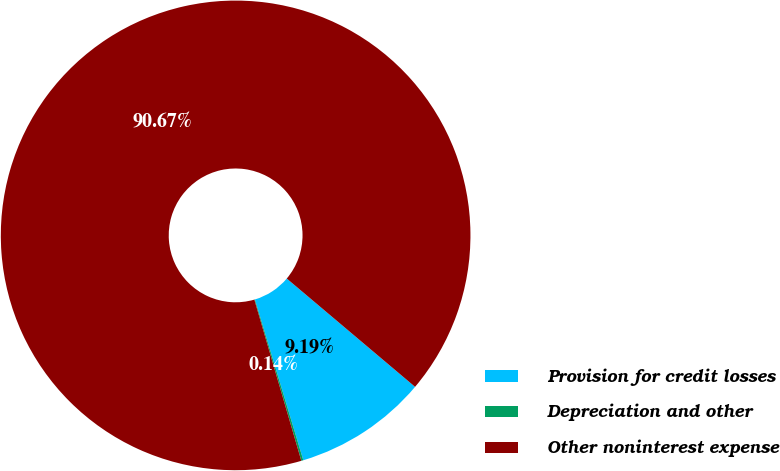Convert chart. <chart><loc_0><loc_0><loc_500><loc_500><pie_chart><fcel>Provision for credit losses<fcel>Depreciation and other<fcel>Other noninterest expense<nl><fcel>9.19%<fcel>0.14%<fcel>90.67%<nl></chart> 